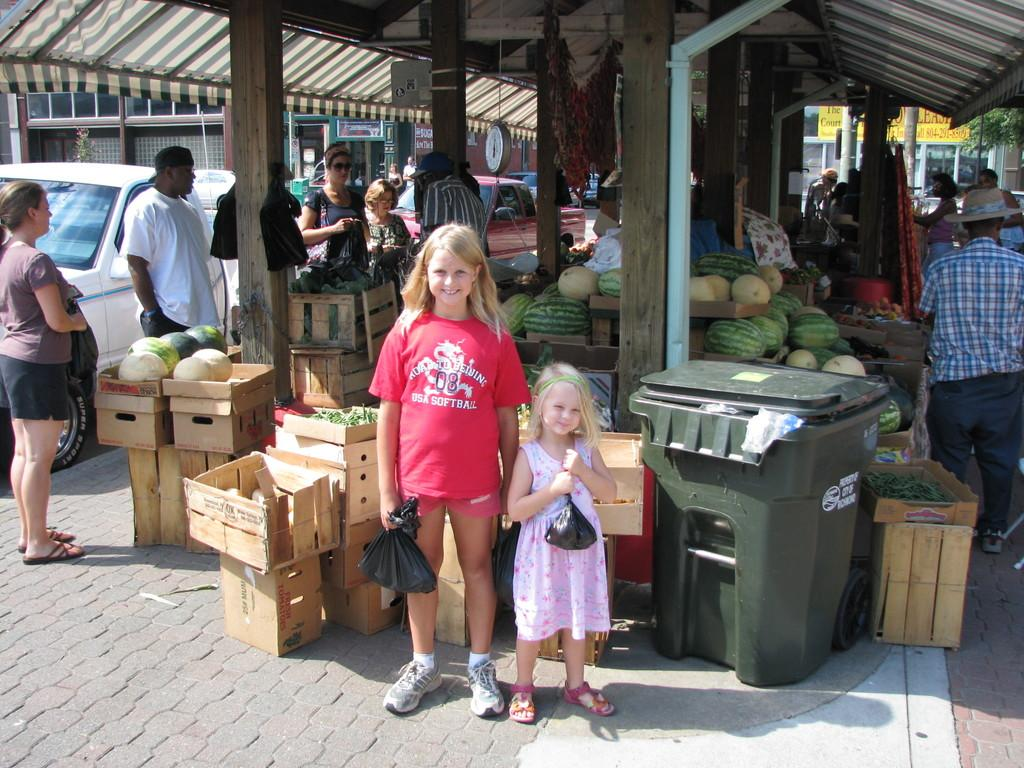<image>
Give a short and clear explanation of the subsequent image. A girl wearing a red USA Softball shirts stands in front of the farmers market 